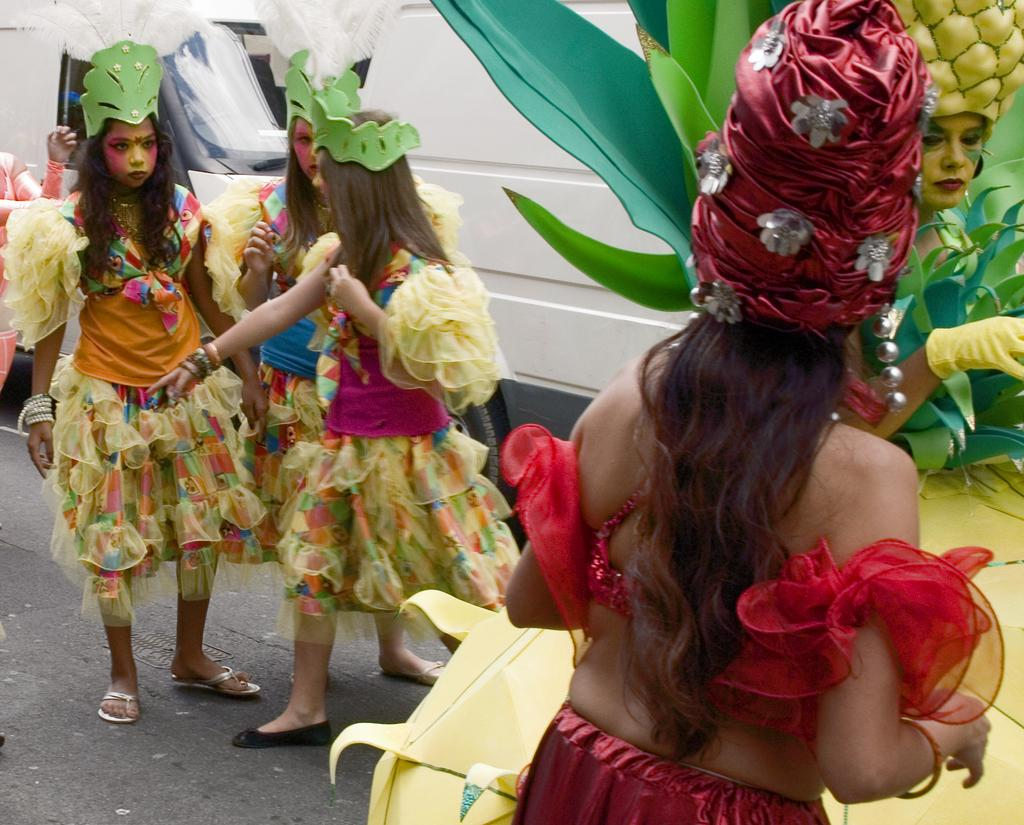How many people are standing on the road in the image? There are five people standing on the road in the image. What are the people wearing? The people are wearing fancy dresses. Can you describe the background of the image? There is a vehicle visible in the background. Are there any other people in the image besides the five standing on the road? Yes, there is another person in the left corner of the image. What type of food is being served to the people in the image? There is no food present in the image; the people are wearing fancy dresses and standing on the road. 